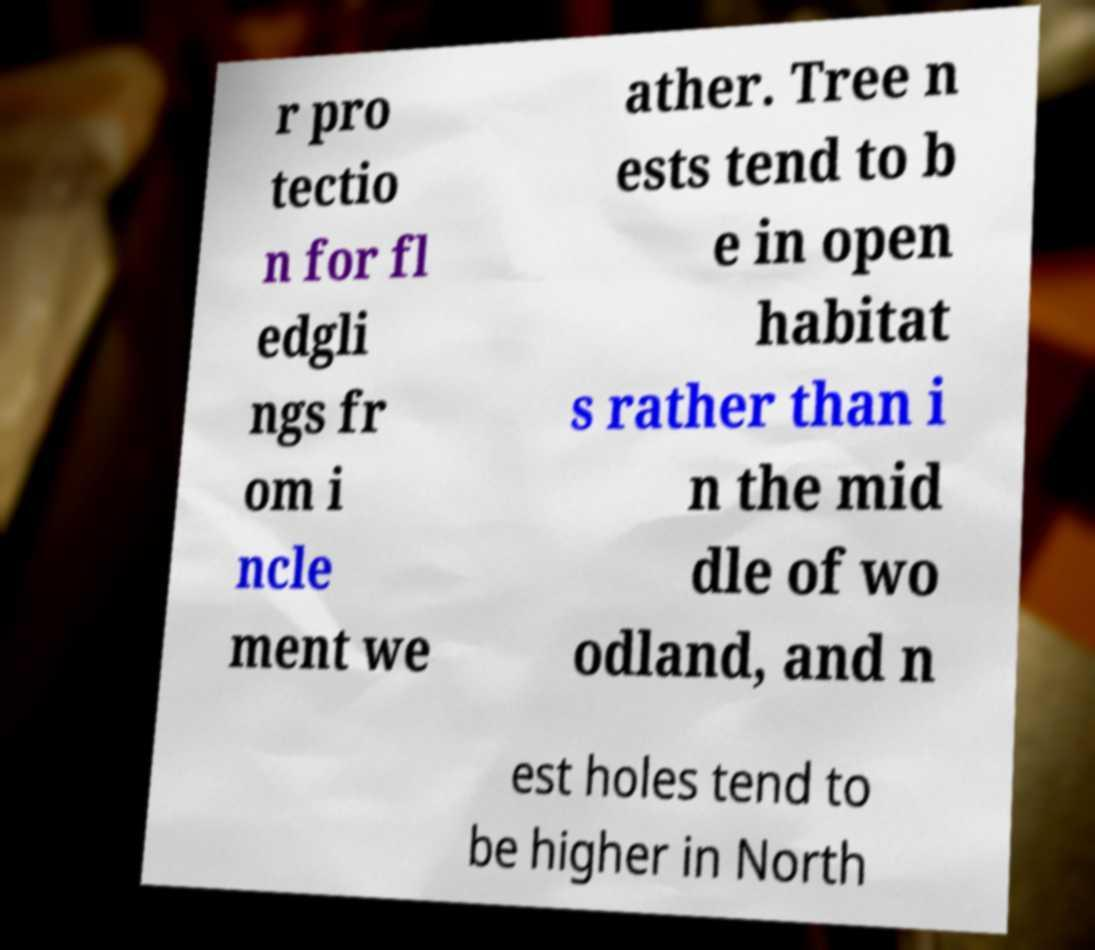Please read and relay the text visible in this image. What does it say? r pro tectio n for fl edgli ngs fr om i ncle ment we ather. Tree n ests tend to b e in open habitat s rather than i n the mid dle of wo odland, and n est holes tend to be higher in North 